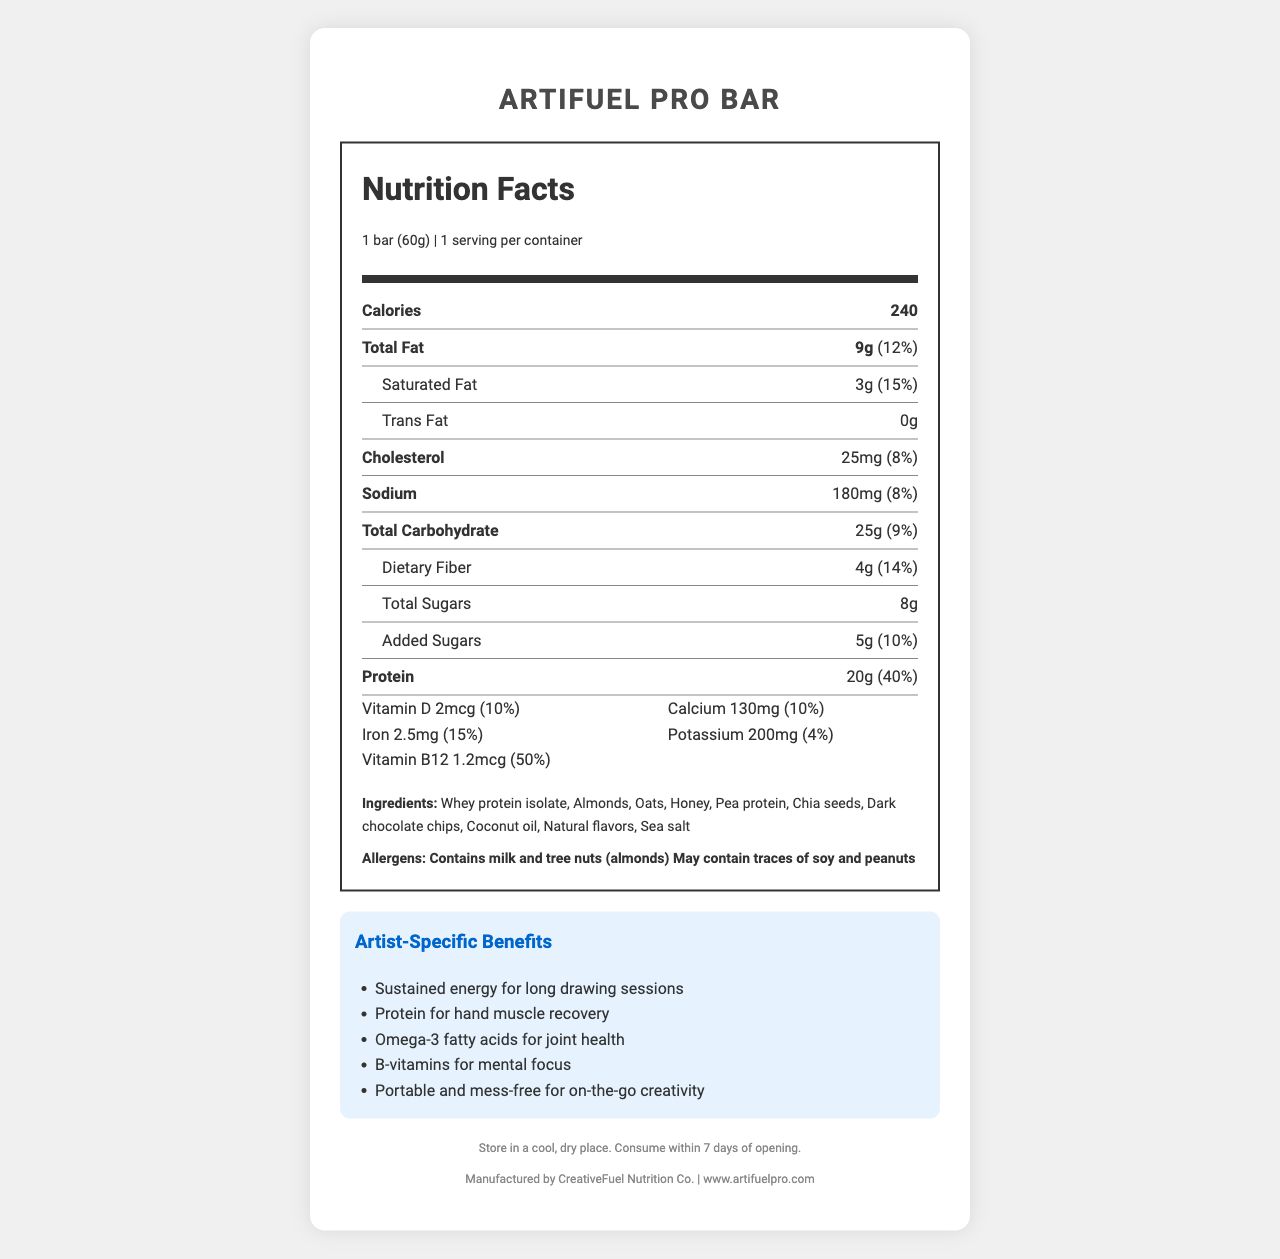what is the serving size of ArtiFuel Pro Bar? The serving size is clearly stated in the document at the top.
Answer: 1 bar (60g) how many calories does one ArtiFuel Pro Bar contain? The document lists the calories in a prominent section.
Answer: 240 calories what is the total amount of fat in one serving? The total fat content is listed as 9g in the nutrition facts.
Answer: 9g how much protein does one ArtiFuel Pro Bar provide? The protein content is specified in the nutrition facts as 20g.
Answer: 20g are there any allergens in the ArtiFuel Pro Bar? The document specifies the allergens in a distinct section.
Answer: Contains milk and tree nuts (almonds); may contain traces of soy and peanuts which ingredient is NOT listed in ArtiFuel Pro Bar? A. Almonds B. Whey protein isolate C. Peanuts Peanuts are not listed in the ingredients, although it may contain traces of them.
Answer: C what percentage of the daily value for saturated fat does one ArtiFuel Pro Bar provide? The daily value percentage for saturated fat is listed as 15%.
Answer: 15% is there any dietary fiber in the ArtiFuel Pro Bar? The amount of dietary fiber is listed as 4g which constitutes 14% of the daily value.
Answer: Yes which of the following benefits is mentioned for artists who consume ArtiFuel Pro Bar? A. Improved eyesight B. Omega-3 fatty acids for joint health C. Faster hair growth The document lists "Omega-3 fatty acids for joint health" as a benefit.
Answer: B does one ArtiFuel Pro Bar contain any trans fat? The document explicitly states that there is 0g of trans fat.
Answer: No summarize the key nutritional information and benefits of ArtiFuel Pro Bar for artists. The document provides comprehensive nutritional values and specific benefits for artists, emphasizing its convenience and health benefits.
Answer: ArtiFuel Pro Bar provides 240 calories per serving with 20g of protein, 9g of fat, and 25g of carbohydrates. It contains vitamins and minerals such as Vitamin D, Calcium, Iron, Potassium, and B12. This snack bar is designed specifically for artists, offering benefits such as sustained energy, hand muscle recovery, joint health, mental focus, and portability. what is the recommended storage instruction for ArtiFuel Pro Bar? The storage instructions are provided clearly at the bottom of the document.
Answer: Store in a cool, dry place. Consume within 7 days of opening. who manufactures ArtiFuel Pro Bar? The manufacturer is mentioned at the end of the document along with the website.
Answer: CreativeFuel Nutrition Co. is the exact number of bars per container mentioned in the document? The document states that there is 1 serving per container.
Answer: Yes what flavors is ArtiFuel Pro Bar available in? The document does not mention any specific flavors of the product.
Answer: Not enough information what is the total carbohydrate content and its daily value percentage? The total carbohydrate content is listed as 25g and contributes to 9% of the daily value.
Answer: 25g, 9% 